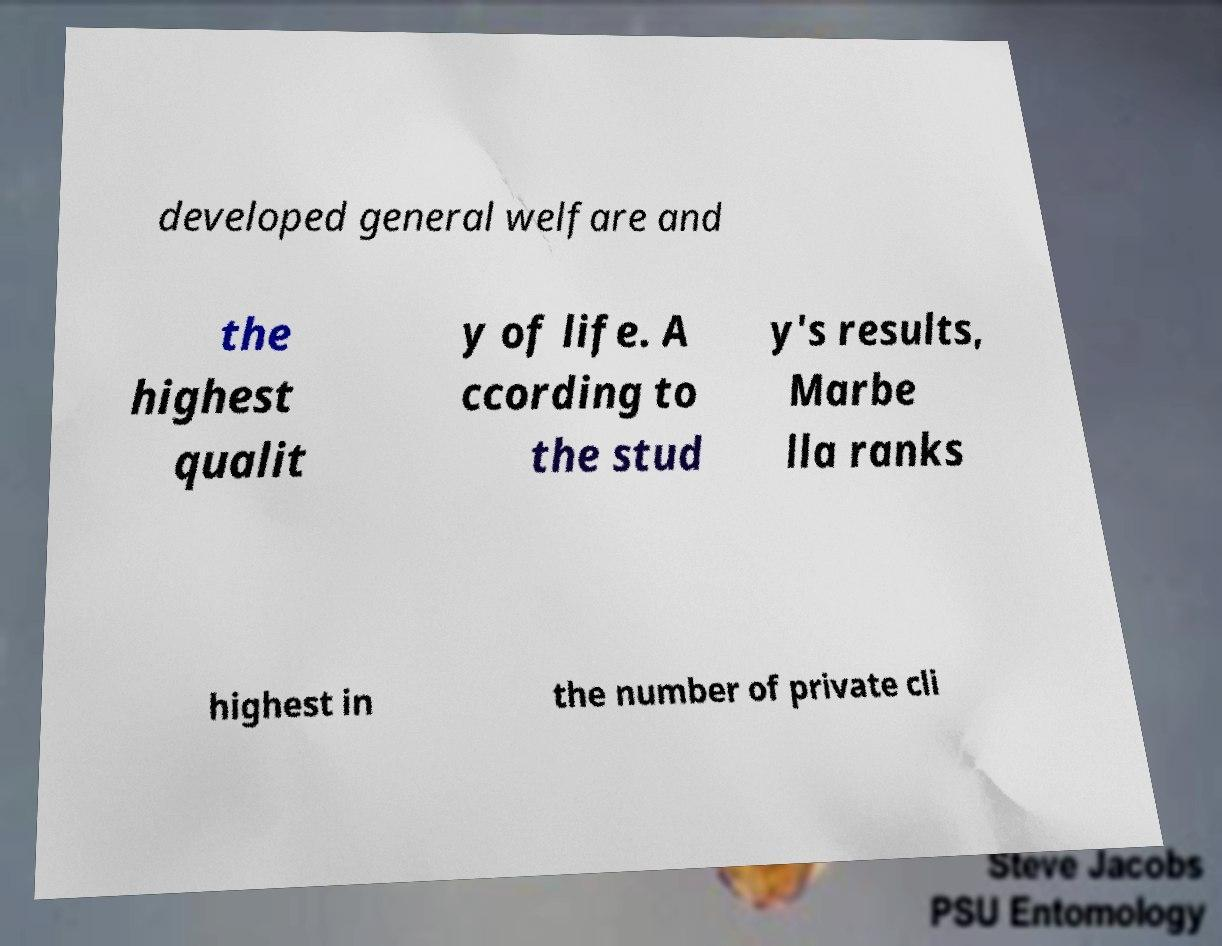Please identify and transcribe the text found in this image. developed general welfare and the highest qualit y of life. A ccording to the stud y's results, Marbe lla ranks highest in the number of private cli 